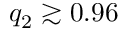<formula> <loc_0><loc_0><loc_500><loc_500>q _ { 2 } \gtrsim 0 . 9 6</formula> 